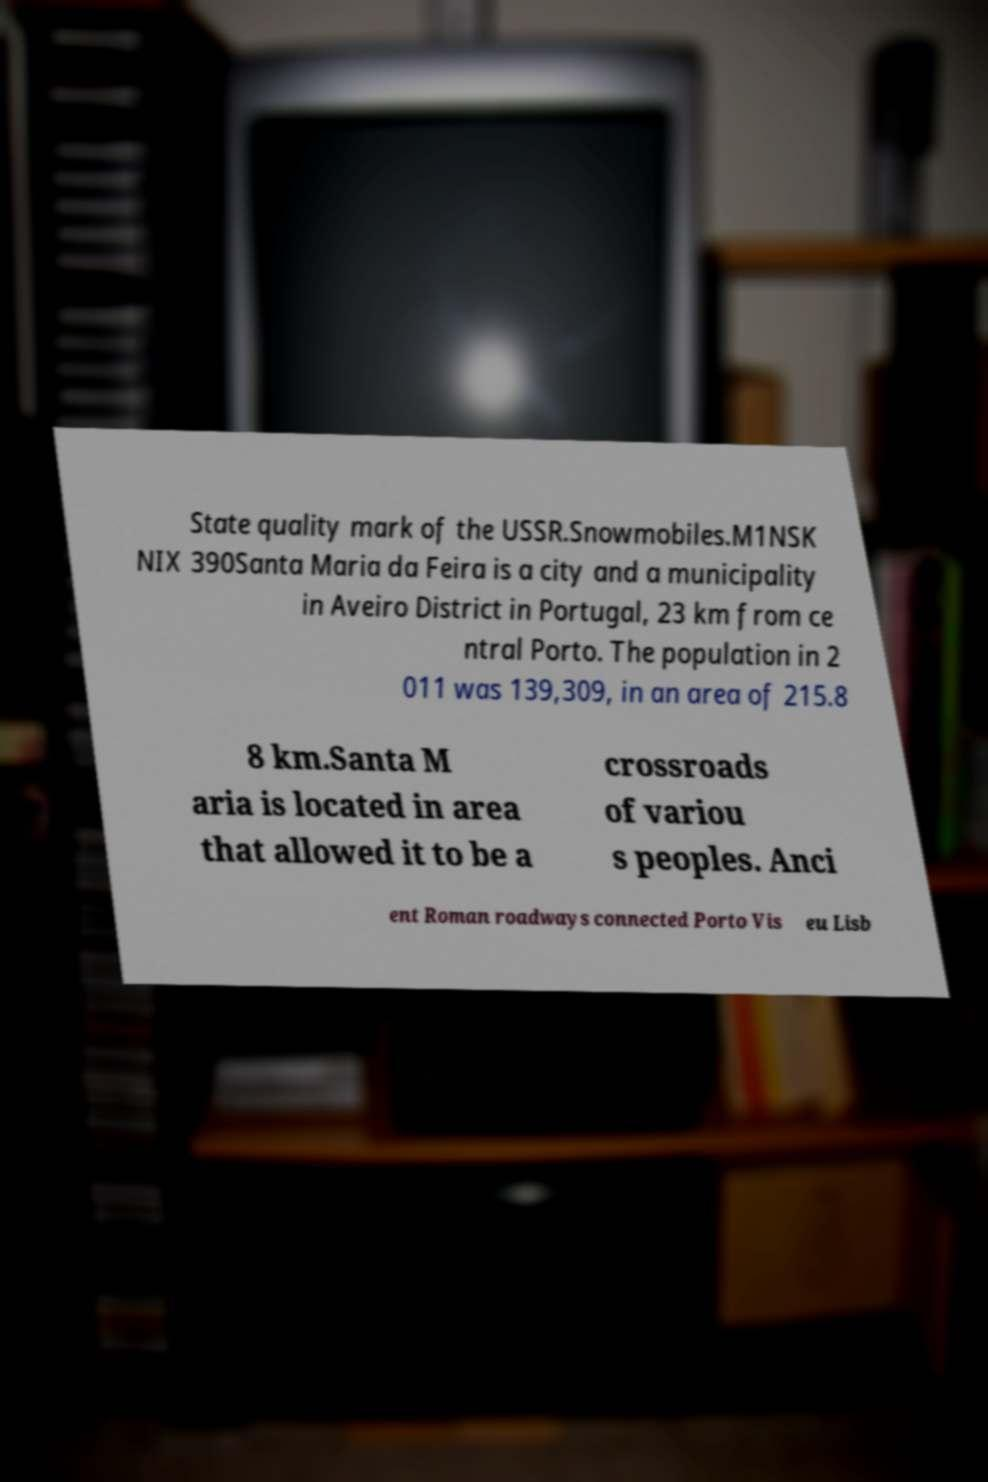For documentation purposes, I need the text within this image transcribed. Could you provide that? State quality mark of the USSR.Snowmobiles.M1NSK NIX 390Santa Maria da Feira is a city and a municipality in Aveiro District in Portugal, 23 km from ce ntral Porto. The population in 2 011 was 139,309, in an area of 215.8 8 km.Santa M aria is located in area that allowed it to be a crossroads of variou s peoples. Anci ent Roman roadways connected Porto Vis eu Lisb 